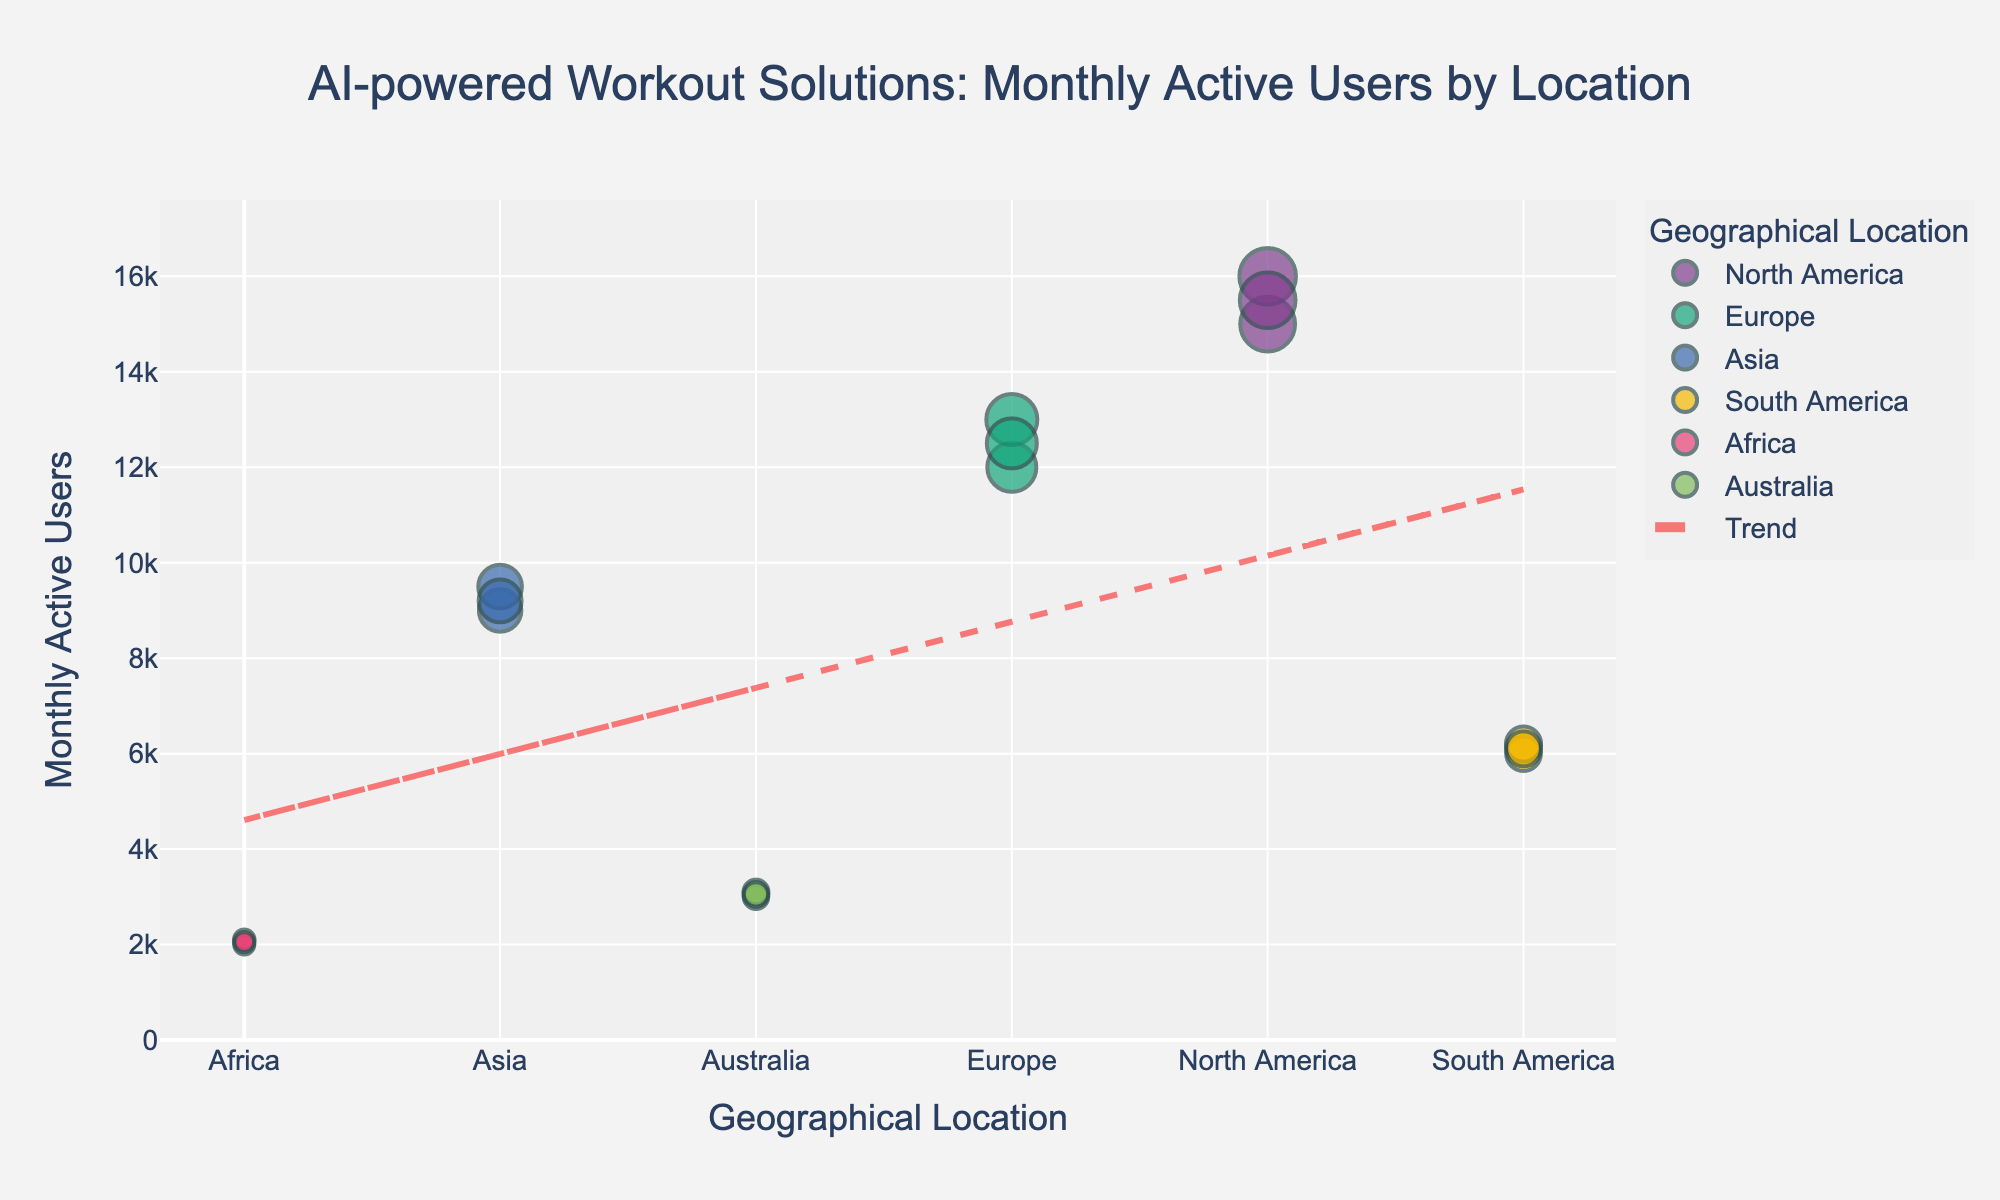How many total geographical locations are represented in the figure? There are six different geographical locations shown in the scatter plot with their corresponding colors.
Answer: 6 Which geographical location has the highest number of monthly active users? According to the scatter plot, North America shows the highest number of monthly active users.
Answer: North America What is the trend of monthly active users across geographical locations, according to the trend line? The trend line on the scatter plot appears to have a slight downward slope, indicating a decrease in monthly active users from North America to Africa.
Answer: Decreasing What is the difference in monthly active users between North America and Africa? The scatter plot shows North America with around 16,000 users and Africa with around 2,100 users. The difference is 16,000 - 2,100.
Answer: 13,900 Which two geographical locations have the closest number of monthly active users? By looking at the scatter plot, Europe and Asia have the closest numbers of monthly active users, both in the range of around 12,000 to 13,000 for Europe and 9,000 to 9,500 for Asia.
Answer: Europe and Asia How does Australia's monthly active users compare to South America? Australia's monthly active users are slightly higher than South America's, according to the scattered points on the plot.
Answer: Higher Is there any geographical location with less than 5,000 monthly active users? Yes, both Africa and Australia have data points below 5,000 monthly active users.
Answer: Yes Which geographical location shows the most variation in monthly active users? North America shows the greatest variation in monthly active users, with values ranging from 15,000 to 16,000.
Answer: North America What is the range of monthly active users seen for Asia? Asia has the monthly active users ranging from 9,000 to 9,500.
Answer: 500 List the geographical locations in descending order based on their average monthly active users. The average numbers can be calculated from the data points and arranged in descending order: North America (15,500), Europe (12,500), Asia (9,233), South America (6,100), Australia (3,050), Africa (2,050).
Answer: North America, Europe, Asia, South America, Australia, Africa 